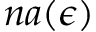Convert formula to latex. <formula><loc_0><loc_0><loc_500><loc_500>n a ( \epsilon )</formula> 